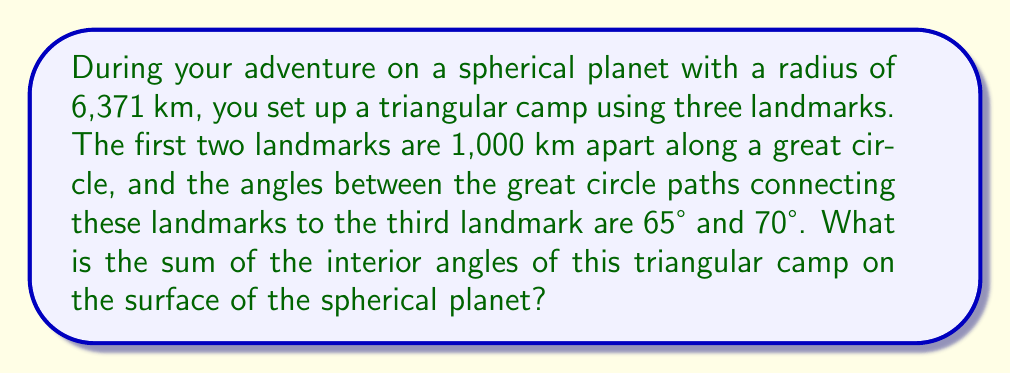Can you answer this question? Let's approach this step-by-step:

1) On a sphere, the sum of angles in a triangle is greater than 180°. The excess over 180° is proportional to the area of the triangle.

2) The formula for the sum of angles in a spherical triangle is:
   $$\alpha + \beta + \gamma = 180° + \frac{A}{R^2}$$
   where $\alpha$, $\beta$, and $\gamma$ are the angles of the triangle, $A$ is the area of the triangle, and $R$ is the radius of the sphere.

3) We're given two angles: 65° and 70°. Let's call the third angle $\theta$.

4) To find the area $A$, we can use the spherical excess formula:
   $$A = (\alpha + \beta + \gamma - 180°) R^2$$

5) Substituting what we know:
   $$A = (65° + 70° + \theta - 180°) (6371)^2$$

6) Now, let's use the formula for the side of a spherical triangle (given two angles and the included side):
   $$\cos(c) = \frac{\cos(1000/6371) - \cos(65°)\cos(70°)}{\sin(65°)\sin(70°)}$$

7) Solving this (you would use a calculator), we get:
   $$c \approx 78.95°$$

8) Now we have all three angles: 65°, 70°, and 78.95°.

9) The sum is:
   $$65° + 70° + 78.95° = 213.95°$$

This is our final answer, as it represents the sum of the interior angles of the triangular camp on the spherical planet.
Answer: 213.95° 